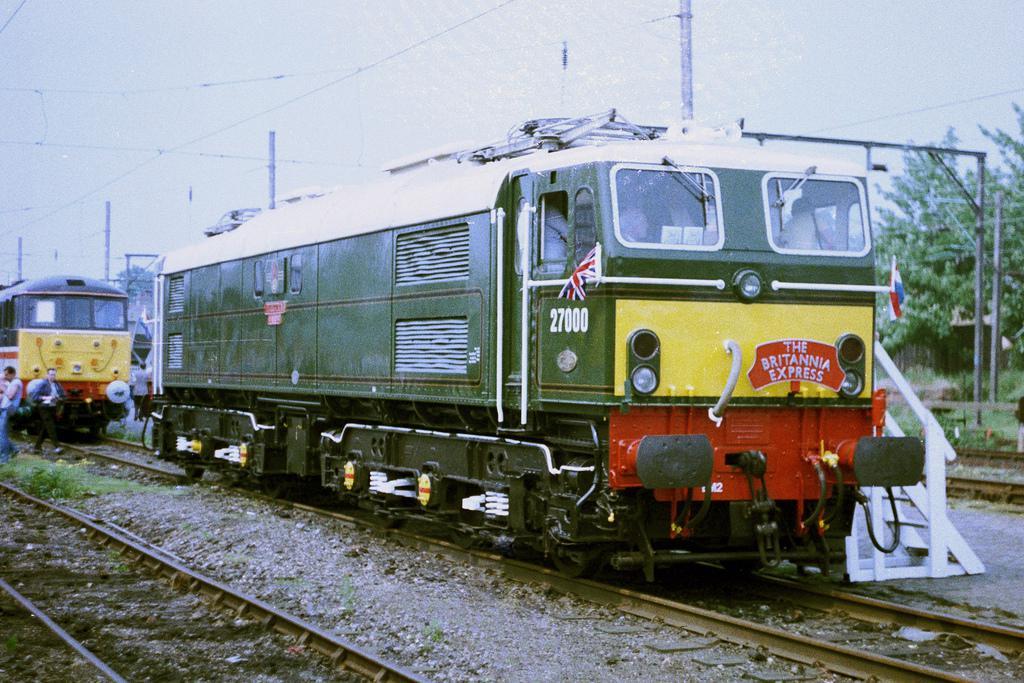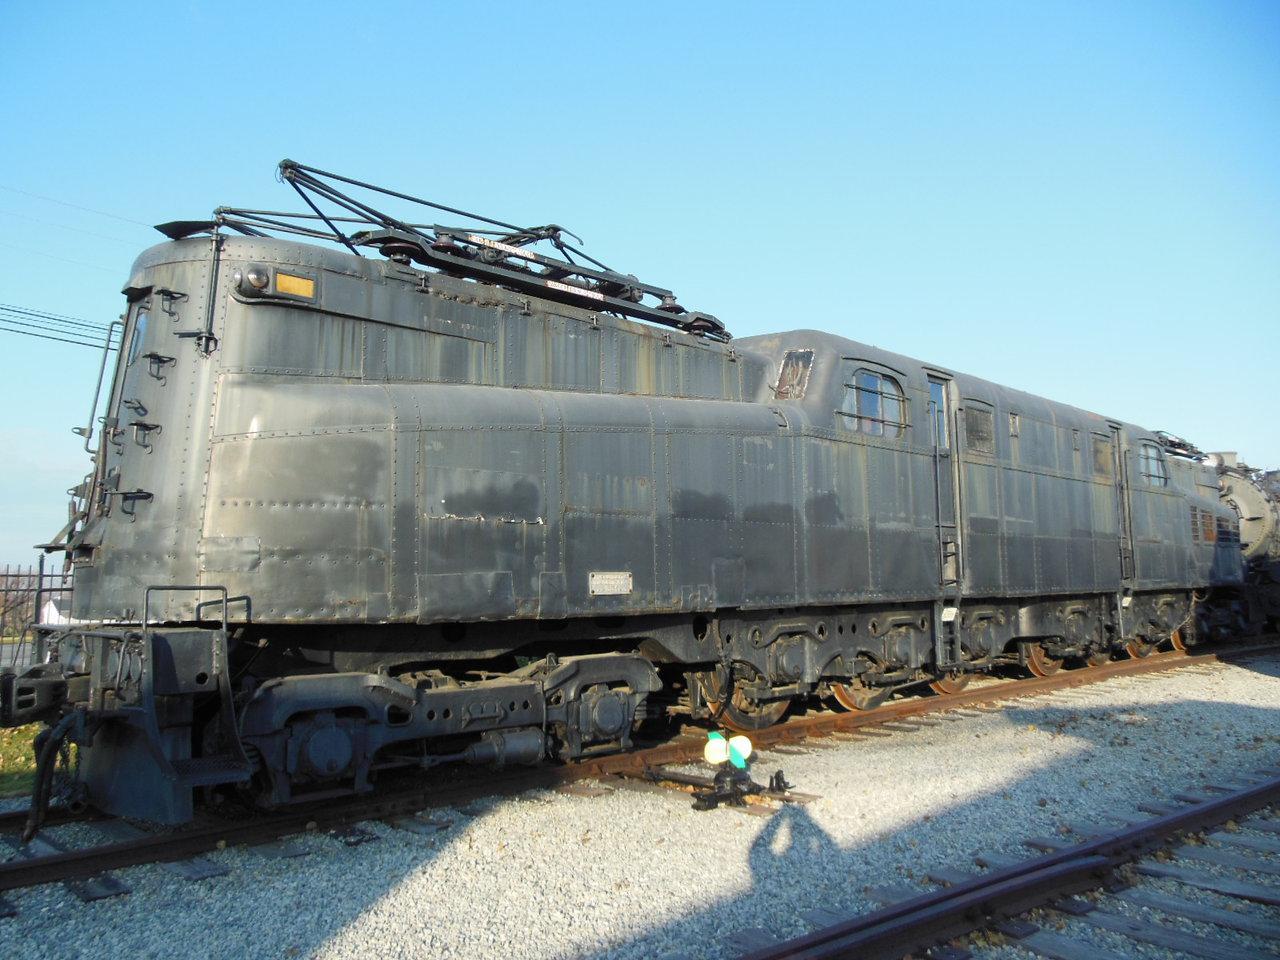The first image is the image on the left, the second image is the image on the right. Assess this claim about the two images: "Right image shows a white train with a red stripe only and an angled front.". Correct or not? Answer yes or no. No. The first image is the image on the left, the second image is the image on the right. Assess this claim about the two images: "One train is white with a single red horizontal stripe around the body.". Correct or not? Answer yes or no. No. 